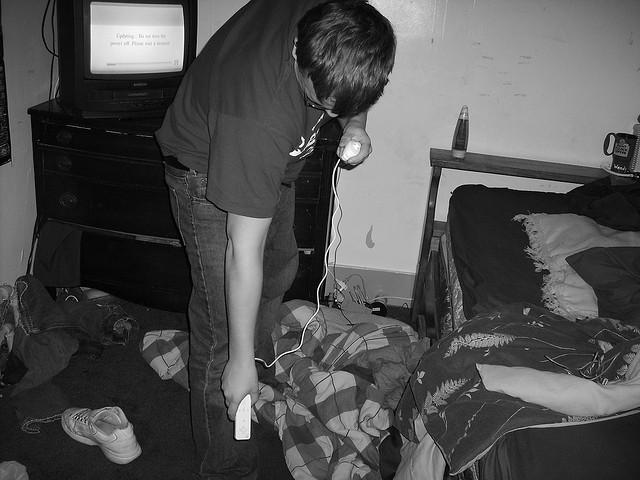What is the video game console connected to the television currently doing?

Choices:
A) updating
B) formatting
C) rebooting
D) starting updating 